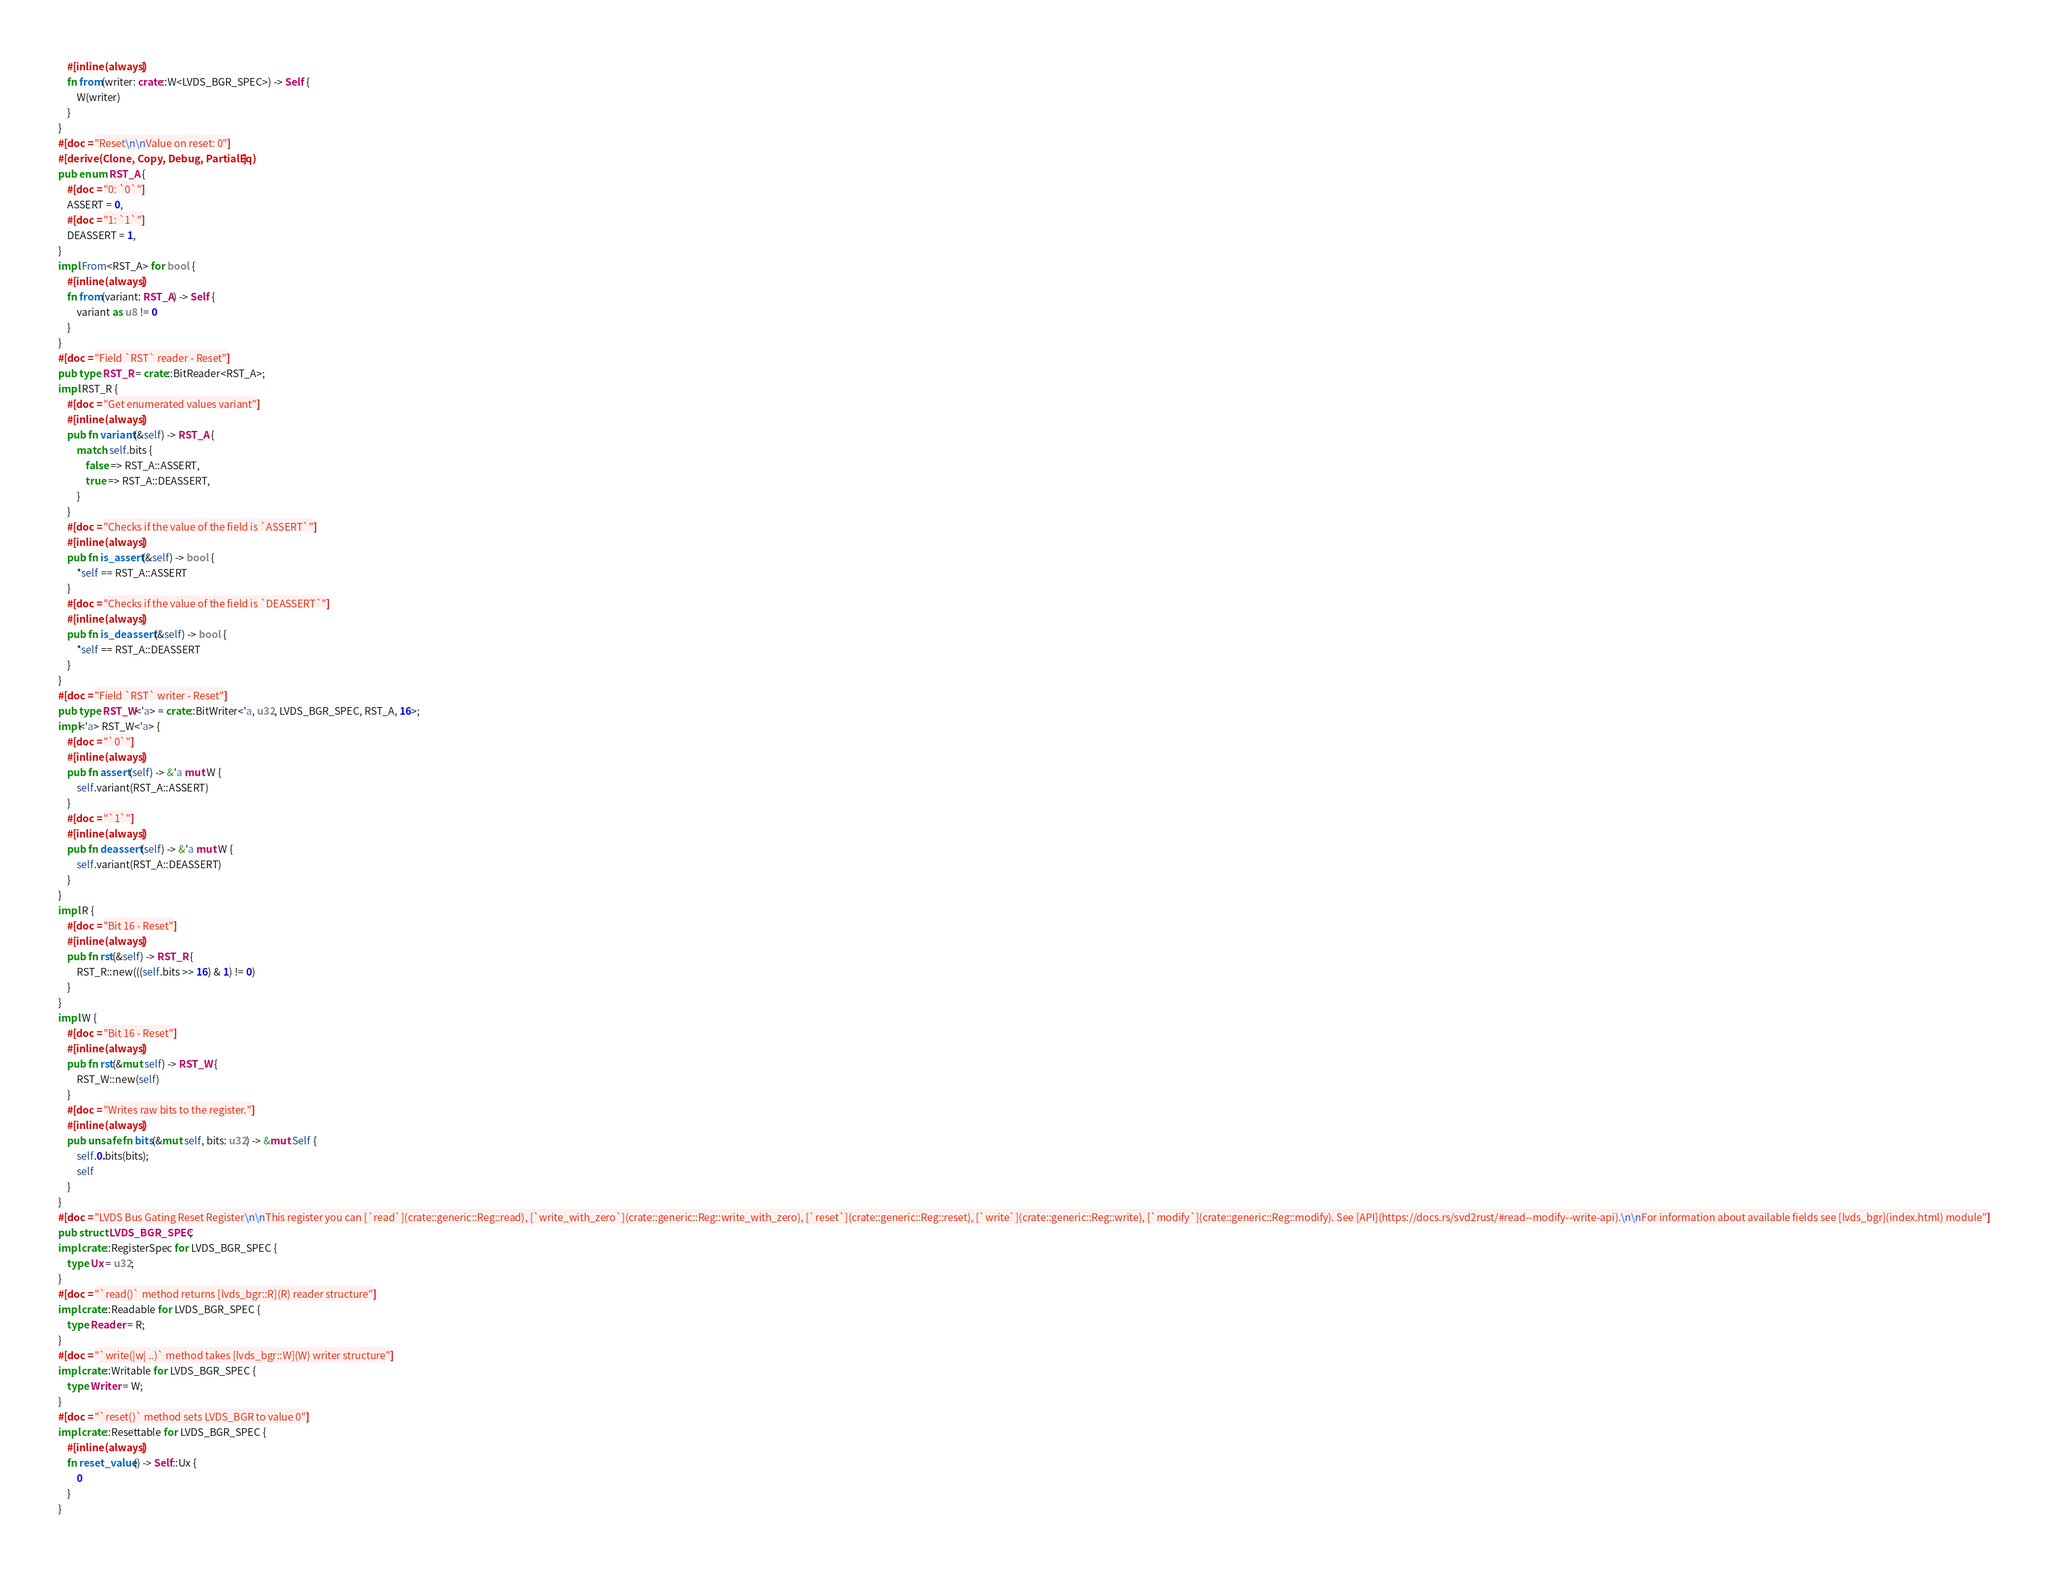<code> <loc_0><loc_0><loc_500><loc_500><_Rust_>    #[inline(always)]
    fn from(writer: crate::W<LVDS_BGR_SPEC>) -> Self {
        W(writer)
    }
}
#[doc = "Reset\n\nValue on reset: 0"]
#[derive(Clone, Copy, Debug, PartialEq)]
pub enum RST_A {
    #[doc = "0: `0`"]
    ASSERT = 0,
    #[doc = "1: `1`"]
    DEASSERT = 1,
}
impl From<RST_A> for bool {
    #[inline(always)]
    fn from(variant: RST_A) -> Self {
        variant as u8 != 0
    }
}
#[doc = "Field `RST` reader - Reset"]
pub type RST_R = crate::BitReader<RST_A>;
impl RST_R {
    #[doc = "Get enumerated values variant"]
    #[inline(always)]
    pub fn variant(&self) -> RST_A {
        match self.bits {
            false => RST_A::ASSERT,
            true => RST_A::DEASSERT,
        }
    }
    #[doc = "Checks if the value of the field is `ASSERT`"]
    #[inline(always)]
    pub fn is_assert(&self) -> bool {
        *self == RST_A::ASSERT
    }
    #[doc = "Checks if the value of the field is `DEASSERT`"]
    #[inline(always)]
    pub fn is_deassert(&self) -> bool {
        *self == RST_A::DEASSERT
    }
}
#[doc = "Field `RST` writer - Reset"]
pub type RST_W<'a> = crate::BitWriter<'a, u32, LVDS_BGR_SPEC, RST_A, 16>;
impl<'a> RST_W<'a> {
    #[doc = "`0`"]
    #[inline(always)]
    pub fn assert(self) -> &'a mut W {
        self.variant(RST_A::ASSERT)
    }
    #[doc = "`1`"]
    #[inline(always)]
    pub fn deassert(self) -> &'a mut W {
        self.variant(RST_A::DEASSERT)
    }
}
impl R {
    #[doc = "Bit 16 - Reset"]
    #[inline(always)]
    pub fn rst(&self) -> RST_R {
        RST_R::new(((self.bits >> 16) & 1) != 0)
    }
}
impl W {
    #[doc = "Bit 16 - Reset"]
    #[inline(always)]
    pub fn rst(&mut self) -> RST_W {
        RST_W::new(self)
    }
    #[doc = "Writes raw bits to the register."]
    #[inline(always)]
    pub unsafe fn bits(&mut self, bits: u32) -> &mut Self {
        self.0.bits(bits);
        self
    }
}
#[doc = "LVDS Bus Gating Reset Register\n\nThis register you can [`read`](crate::generic::Reg::read), [`write_with_zero`](crate::generic::Reg::write_with_zero), [`reset`](crate::generic::Reg::reset), [`write`](crate::generic::Reg::write), [`modify`](crate::generic::Reg::modify). See [API](https://docs.rs/svd2rust/#read--modify--write-api).\n\nFor information about available fields see [lvds_bgr](index.html) module"]
pub struct LVDS_BGR_SPEC;
impl crate::RegisterSpec for LVDS_BGR_SPEC {
    type Ux = u32;
}
#[doc = "`read()` method returns [lvds_bgr::R](R) reader structure"]
impl crate::Readable for LVDS_BGR_SPEC {
    type Reader = R;
}
#[doc = "`write(|w| ..)` method takes [lvds_bgr::W](W) writer structure"]
impl crate::Writable for LVDS_BGR_SPEC {
    type Writer = W;
}
#[doc = "`reset()` method sets LVDS_BGR to value 0"]
impl crate::Resettable for LVDS_BGR_SPEC {
    #[inline(always)]
    fn reset_value() -> Self::Ux {
        0
    }
}
</code> 